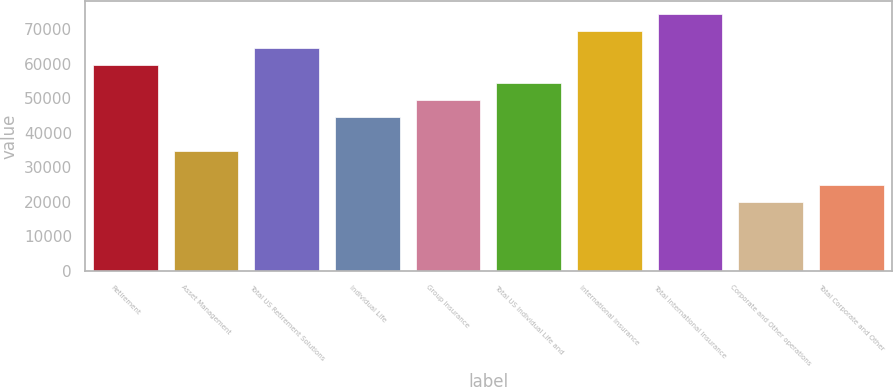<chart> <loc_0><loc_0><loc_500><loc_500><bar_chart><fcel>Retirement<fcel>Asset Management<fcel>Total US Retirement Solutions<fcel>Individual Life<fcel>Group Insurance<fcel>Total US Individual Life and<fcel>International Insurance<fcel>Total International Insurance<fcel>Corporate and Other operations<fcel>Total Corporate and Other<nl><fcel>59572.4<fcel>34751.2<fcel>64536.7<fcel>44679.7<fcel>49644<fcel>54608.2<fcel>69500.9<fcel>74465.2<fcel>19858.5<fcel>24822.8<nl></chart> 